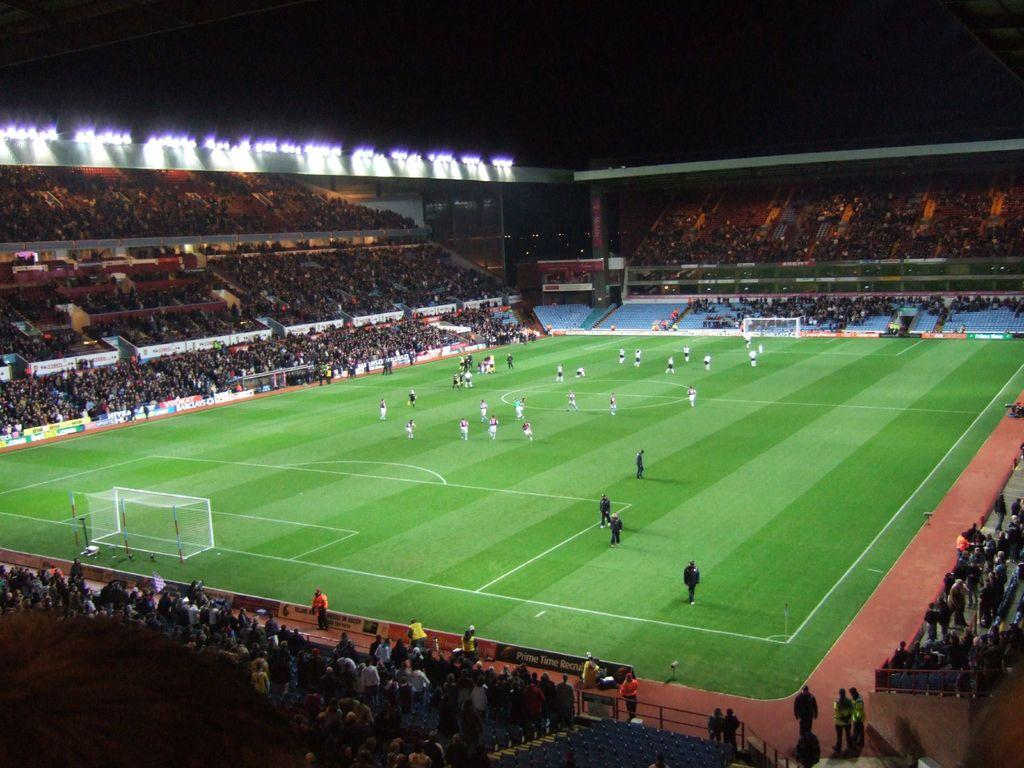What are the people in the image doing? There are people sitting on chairs in the image. What else can be seen on the ground in the image? There are players on the ground in the image. What is the purpose of the net visible in the image? The net is likely used for a game or sport. Where are the stairs located in the image? The stairs are present in the image. What is the source of illumination at the top of the image? Lights are present at the top of the image. Can you see any deer in the image? No, there are no deer present in the image. What type of plastic material can be seen in the image? There is no plastic material visible in the image. 